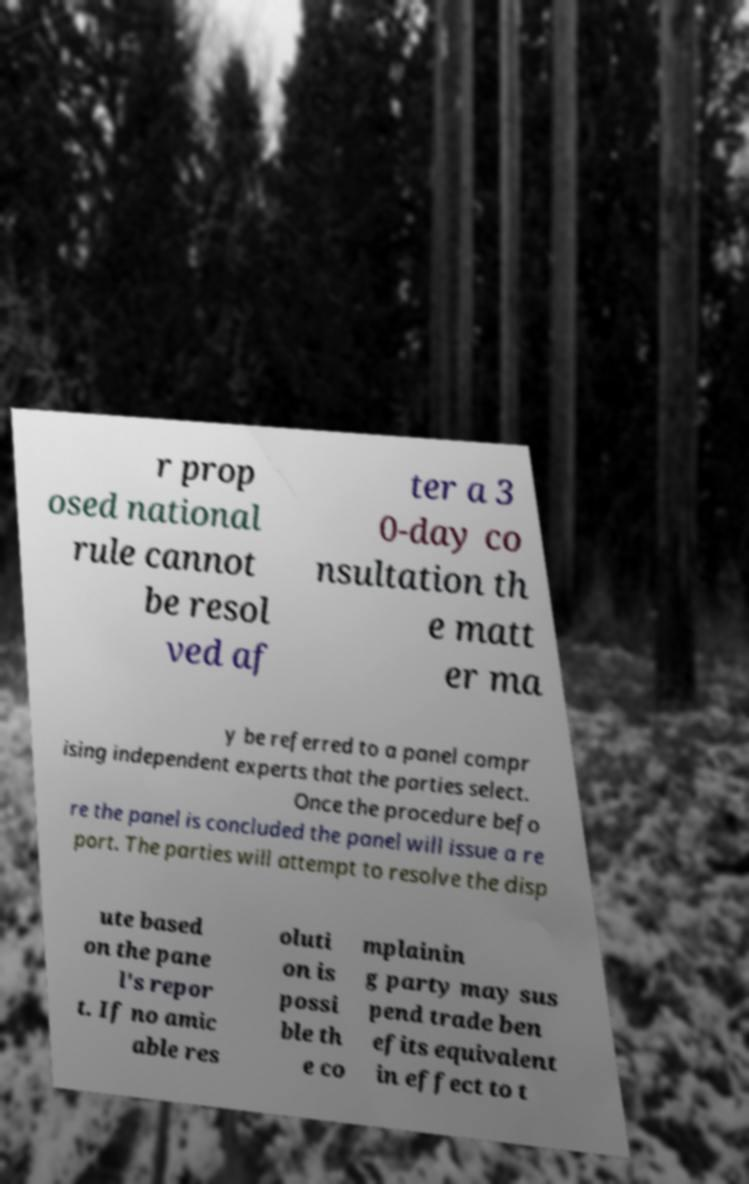I need the written content from this picture converted into text. Can you do that? r prop osed national rule cannot be resol ved af ter a 3 0-day co nsultation th e matt er ma y be referred to a panel compr ising independent experts that the parties select. Once the procedure befo re the panel is concluded the panel will issue a re port. The parties will attempt to resolve the disp ute based on the pane l's repor t. If no amic able res oluti on is possi ble th e co mplainin g party may sus pend trade ben efits equivalent in effect to t 